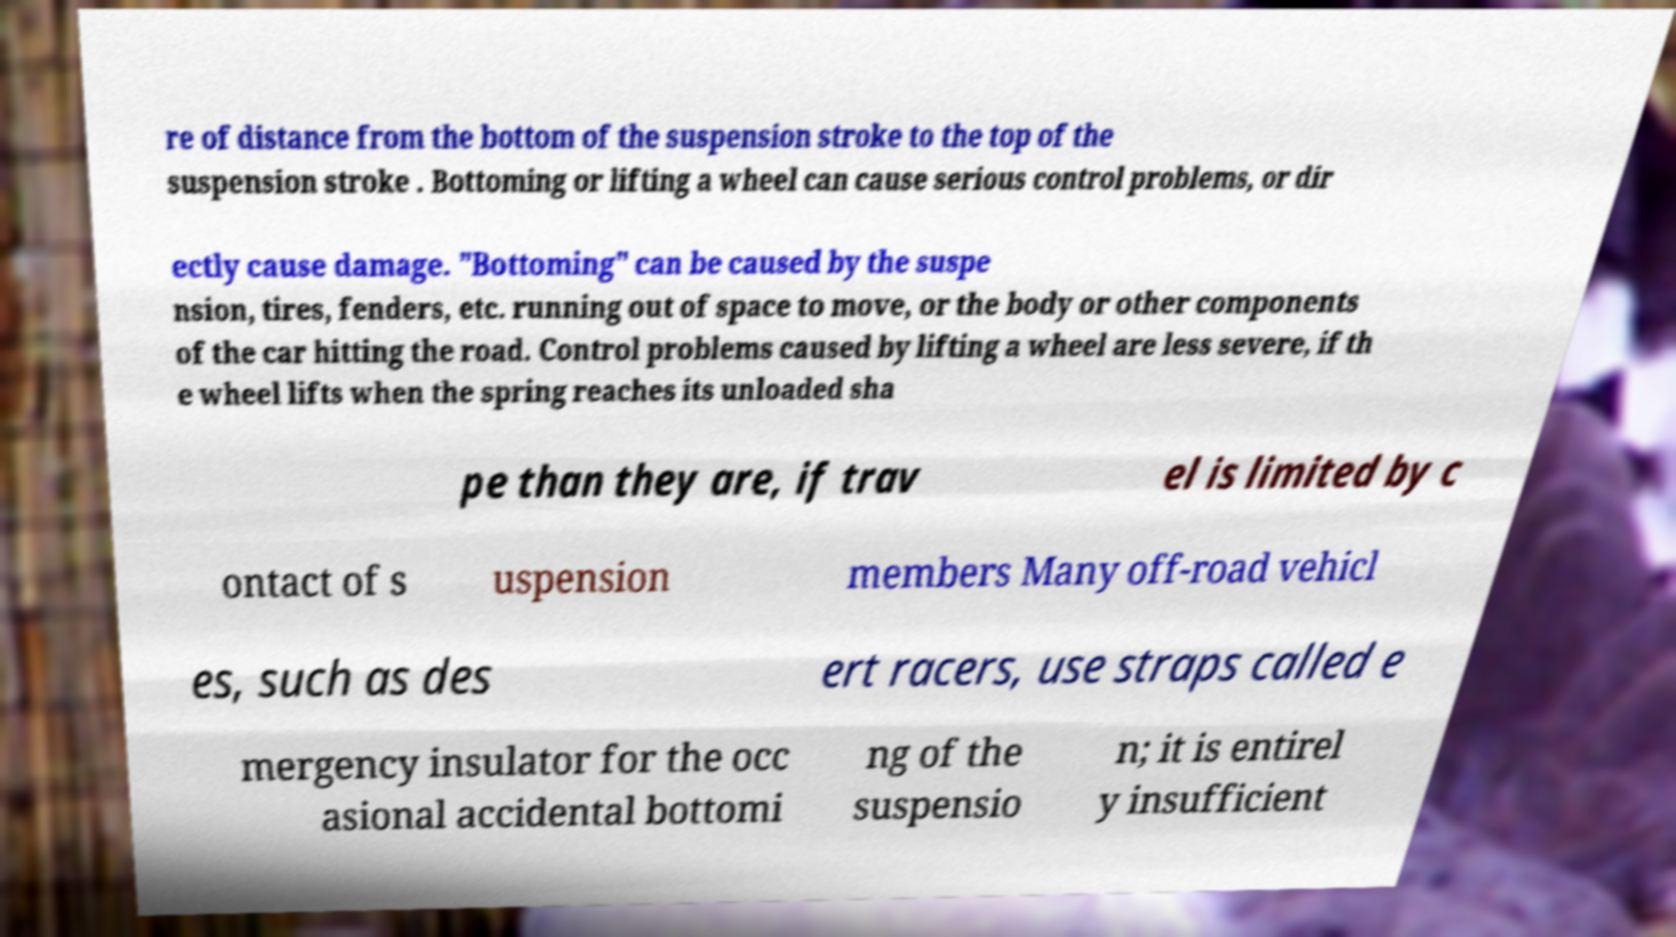For documentation purposes, I need the text within this image transcribed. Could you provide that? re of distance from the bottom of the suspension stroke to the top of the suspension stroke . Bottoming or lifting a wheel can cause serious control problems, or dir ectly cause damage. "Bottoming" can be caused by the suspe nsion, tires, fenders, etc. running out of space to move, or the body or other components of the car hitting the road. Control problems caused by lifting a wheel are less severe, if th e wheel lifts when the spring reaches its unloaded sha pe than they are, if trav el is limited by c ontact of s uspension members Many off-road vehicl es, such as des ert racers, use straps called e mergency insulator for the occ asional accidental bottomi ng of the suspensio n; it is entirel y insufficient 